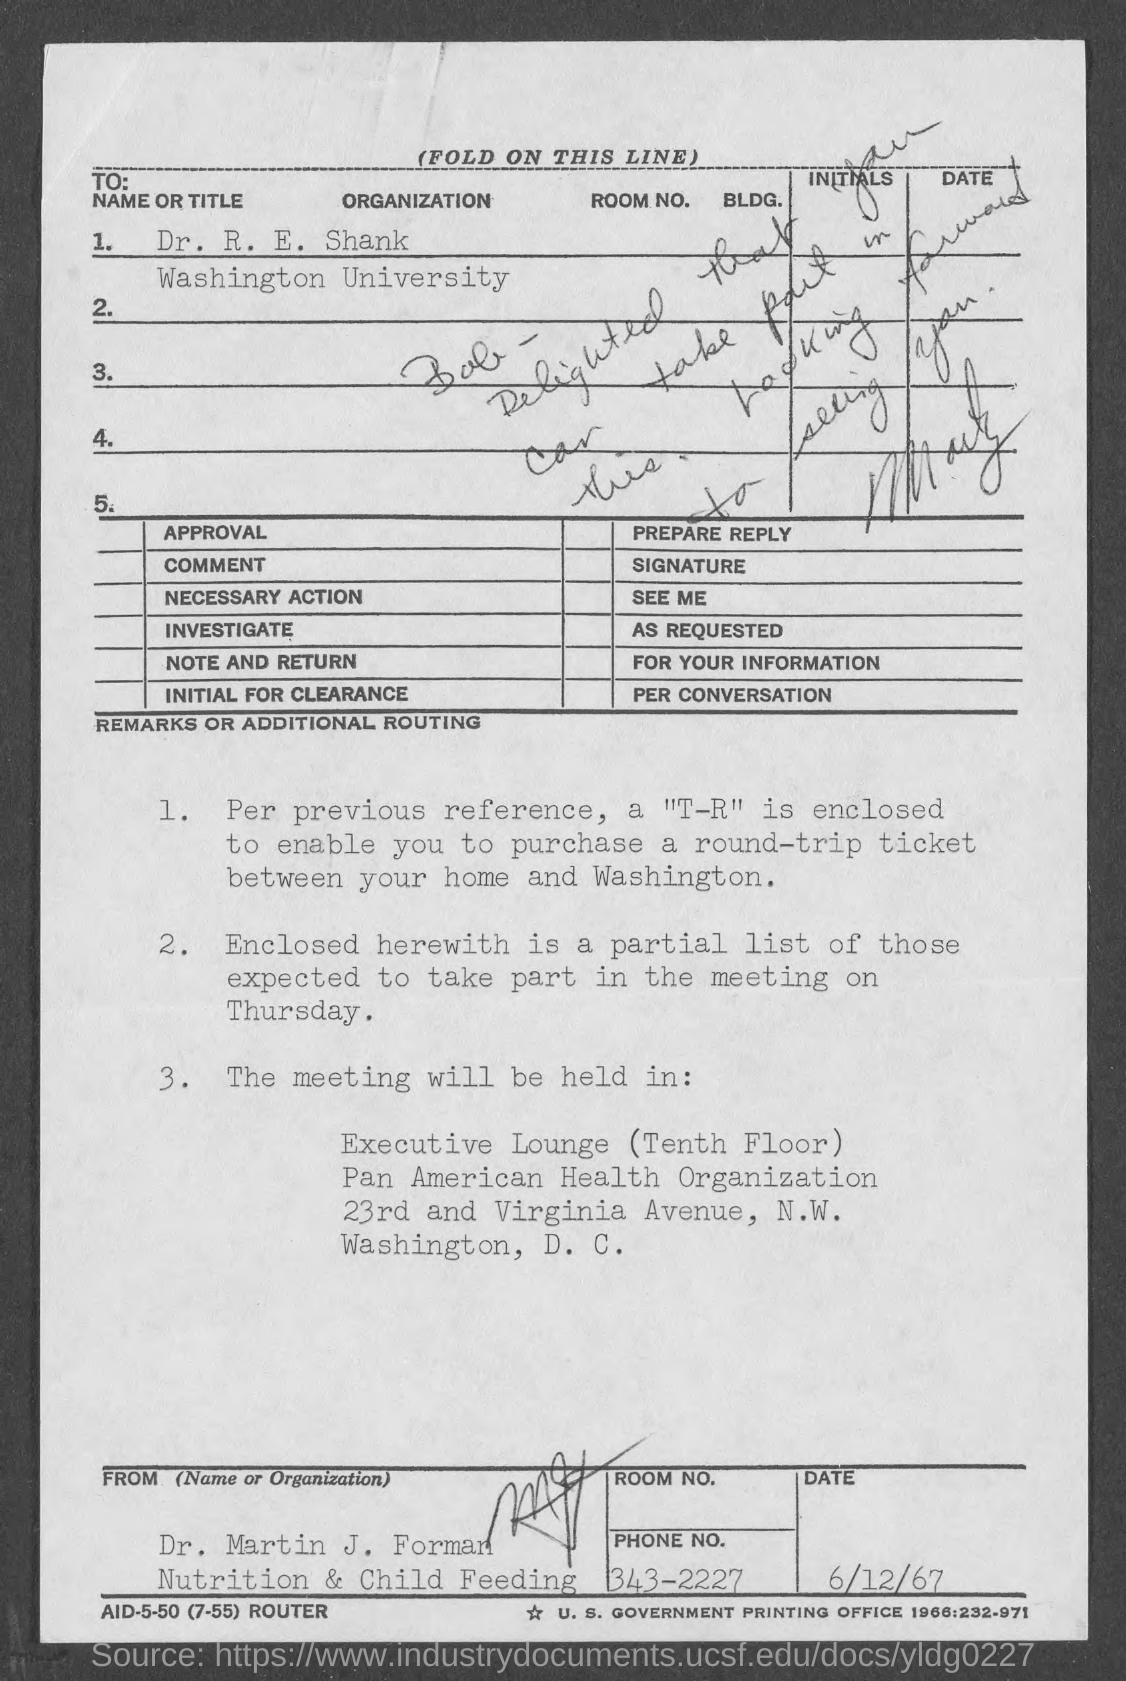What is the to name or title ?
Provide a short and direct response. Dr. R. E. Shank. To which university does dr. r.e. shank belong ?
Your response must be concise. Washington University. What is the date at bottom of the page?
Offer a terse response. 6/12/67. What is the avenue address of pan america health organisation ?
Keep it short and to the point. 23rd and Virginia Avenue. What is the venue for meeting ?
Provide a short and direct response. Executive Lounge. 